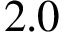<formula> <loc_0><loc_0><loc_500><loc_500>2 . 0</formula> 